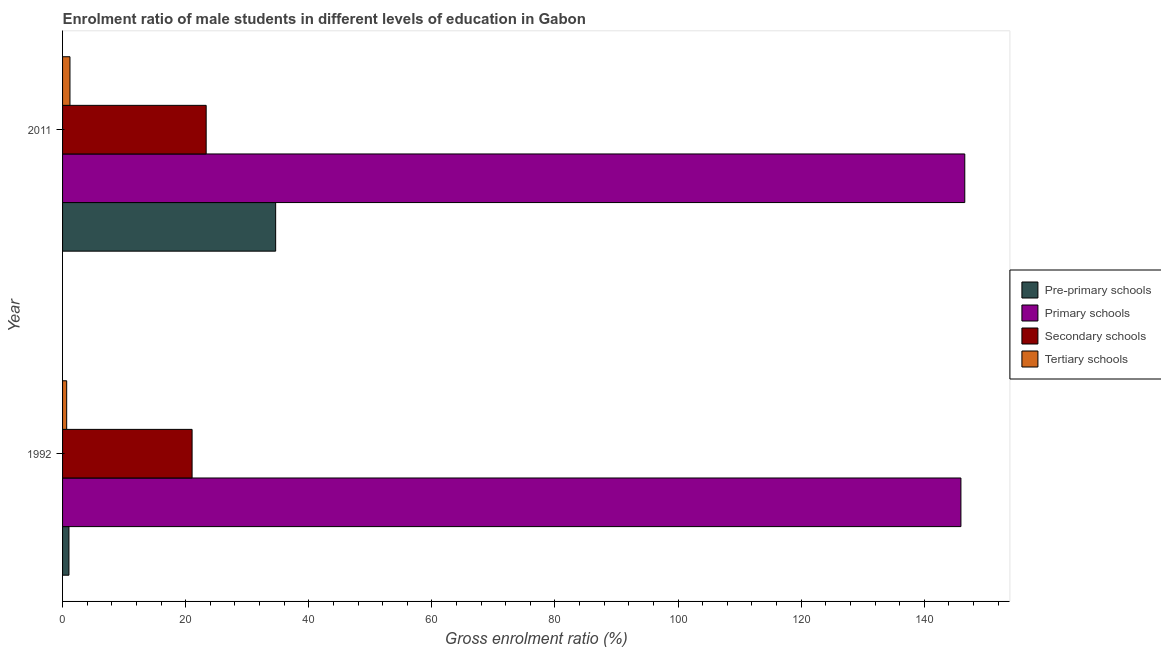How many different coloured bars are there?
Your response must be concise. 4. Are the number of bars per tick equal to the number of legend labels?
Give a very brief answer. Yes. How many bars are there on the 2nd tick from the top?
Ensure brevity in your answer.  4. How many bars are there on the 2nd tick from the bottom?
Provide a succinct answer. 4. What is the gross enrolment ratio(female) in pre-primary schools in 1992?
Your answer should be compact. 1.04. Across all years, what is the maximum gross enrolment ratio(female) in tertiary schools?
Provide a succinct answer. 1.2. Across all years, what is the minimum gross enrolment ratio(female) in primary schools?
Your answer should be very brief. 145.96. What is the total gross enrolment ratio(female) in secondary schools in the graph?
Offer a very short reply. 44.38. What is the difference between the gross enrolment ratio(female) in pre-primary schools in 1992 and that in 2011?
Your answer should be compact. -33.59. What is the difference between the gross enrolment ratio(female) in secondary schools in 1992 and the gross enrolment ratio(female) in tertiary schools in 2011?
Your answer should be very brief. 19.84. What is the average gross enrolment ratio(female) in tertiary schools per year?
Provide a succinct answer. 0.94. In the year 2011, what is the difference between the gross enrolment ratio(female) in primary schools and gross enrolment ratio(female) in tertiary schools?
Offer a very short reply. 145.39. In how many years, is the gross enrolment ratio(female) in tertiary schools greater than 36 %?
Keep it short and to the point. 0. What is the ratio of the gross enrolment ratio(female) in secondary schools in 1992 to that in 2011?
Keep it short and to the point. 0.9. Is the gross enrolment ratio(female) in tertiary schools in 1992 less than that in 2011?
Ensure brevity in your answer.  Yes. Is the difference between the gross enrolment ratio(female) in pre-primary schools in 1992 and 2011 greater than the difference between the gross enrolment ratio(female) in tertiary schools in 1992 and 2011?
Offer a very short reply. No. Is it the case that in every year, the sum of the gross enrolment ratio(female) in pre-primary schools and gross enrolment ratio(female) in tertiary schools is greater than the sum of gross enrolment ratio(female) in primary schools and gross enrolment ratio(female) in secondary schools?
Provide a succinct answer. No. What does the 1st bar from the top in 2011 represents?
Make the answer very short. Tertiary schools. What does the 1st bar from the bottom in 1992 represents?
Provide a succinct answer. Pre-primary schools. Is it the case that in every year, the sum of the gross enrolment ratio(female) in pre-primary schools and gross enrolment ratio(female) in primary schools is greater than the gross enrolment ratio(female) in secondary schools?
Your answer should be compact. Yes. Are the values on the major ticks of X-axis written in scientific E-notation?
Give a very brief answer. No. Does the graph contain grids?
Give a very brief answer. No. How many legend labels are there?
Make the answer very short. 4. How are the legend labels stacked?
Ensure brevity in your answer.  Vertical. What is the title of the graph?
Offer a terse response. Enrolment ratio of male students in different levels of education in Gabon. Does "WFP" appear as one of the legend labels in the graph?
Give a very brief answer. No. What is the label or title of the X-axis?
Keep it short and to the point. Gross enrolment ratio (%). What is the Gross enrolment ratio (%) in Pre-primary schools in 1992?
Offer a terse response. 1.04. What is the Gross enrolment ratio (%) in Primary schools in 1992?
Offer a very short reply. 145.96. What is the Gross enrolment ratio (%) of Secondary schools in 1992?
Give a very brief answer. 21.04. What is the Gross enrolment ratio (%) in Tertiary schools in 1992?
Your response must be concise. 0.67. What is the Gross enrolment ratio (%) in Pre-primary schools in 2011?
Give a very brief answer. 34.62. What is the Gross enrolment ratio (%) in Primary schools in 2011?
Provide a short and direct response. 146.59. What is the Gross enrolment ratio (%) in Secondary schools in 2011?
Provide a succinct answer. 23.33. What is the Gross enrolment ratio (%) of Tertiary schools in 2011?
Provide a succinct answer. 1.2. Across all years, what is the maximum Gross enrolment ratio (%) in Pre-primary schools?
Provide a short and direct response. 34.62. Across all years, what is the maximum Gross enrolment ratio (%) in Primary schools?
Your answer should be very brief. 146.59. Across all years, what is the maximum Gross enrolment ratio (%) of Secondary schools?
Make the answer very short. 23.33. Across all years, what is the maximum Gross enrolment ratio (%) of Tertiary schools?
Keep it short and to the point. 1.2. Across all years, what is the minimum Gross enrolment ratio (%) in Pre-primary schools?
Keep it short and to the point. 1.04. Across all years, what is the minimum Gross enrolment ratio (%) in Primary schools?
Your response must be concise. 145.96. Across all years, what is the minimum Gross enrolment ratio (%) in Secondary schools?
Ensure brevity in your answer.  21.04. Across all years, what is the minimum Gross enrolment ratio (%) in Tertiary schools?
Offer a terse response. 0.67. What is the total Gross enrolment ratio (%) in Pre-primary schools in the graph?
Ensure brevity in your answer.  35.66. What is the total Gross enrolment ratio (%) of Primary schools in the graph?
Offer a terse response. 292.55. What is the total Gross enrolment ratio (%) of Secondary schools in the graph?
Your answer should be very brief. 44.38. What is the total Gross enrolment ratio (%) of Tertiary schools in the graph?
Give a very brief answer. 1.87. What is the difference between the Gross enrolment ratio (%) of Pre-primary schools in 1992 and that in 2011?
Your answer should be compact. -33.59. What is the difference between the Gross enrolment ratio (%) in Primary schools in 1992 and that in 2011?
Make the answer very short. -0.63. What is the difference between the Gross enrolment ratio (%) of Secondary schools in 1992 and that in 2011?
Offer a very short reply. -2.29. What is the difference between the Gross enrolment ratio (%) of Tertiary schools in 1992 and that in 2011?
Your response must be concise. -0.53. What is the difference between the Gross enrolment ratio (%) in Pre-primary schools in 1992 and the Gross enrolment ratio (%) in Primary schools in 2011?
Provide a short and direct response. -145.55. What is the difference between the Gross enrolment ratio (%) of Pre-primary schools in 1992 and the Gross enrolment ratio (%) of Secondary schools in 2011?
Provide a short and direct response. -22.3. What is the difference between the Gross enrolment ratio (%) in Pre-primary schools in 1992 and the Gross enrolment ratio (%) in Tertiary schools in 2011?
Give a very brief answer. -0.17. What is the difference between the Gross enrolment ratio (%) in Primary schools in 1992 and the Gross enrolment ratio (%) in Secondary schools in 2011?
Offer a very short reply. 122.63. What is the difference between the Gross enrolment ratio (%) in Primary schools in 1992 and the Gross enrolment ratio (%) in Tertiary schools in 2011?
Your answer should be very brief. 144.76. What is the difference between the Gross enrolment ratio (%) of Secondary schools in 1992 and the Gross enrolment ratio (%) of Tertiary schools in 2011?
Provide a short and direct response. 19.84. What is the average Gross enrolment ratio (%) in Pre-primary schools per year?
Keep it short and to the point. 17.83. What is the average Gross enrolment ratio (%) in Primary schools per year?
Your answer should be very brief. 146.27. What is the average Gross enrolment ratio (%) of Secondary schools per year?
Make the answer very short. 22.19. What is the average Gross enrolment ratio (%) of Tertiary schools per year?
Ensure brevity in your answer.  0.94. In the year 1992, what is the difference between the Gross enrolment ratio (%) in Pre-primary schools and Gross enrolment ratio (%) in Primary schools?
Offer a very short reply. -144.92. In the year 1992, what is the difference between the Gross enrolment ratio (%) in Pre-primary schools and Gross enrolment ratio (%) in Secondary schools?
Offer a terse response. -20.01. In the year 1992, what is the difference between the Gross enrolment ratio (%) in Pre-primary schools and Gross enrolment ratio (%) in Tertiary schools?
Offer a very short reply. 0.37. In the year 1992, what is the difference between the Gross enrolment ratio (%) of Primary schools and Gross enrolment ratio (%) of Secondary schools?
Offer a terse response. 124.92. In the year 1992, what is the difference between the Gross enrolment ratio (%) of Primary schools and Gross enrolment ratio (%) of Tertiary schools?
Your answer should be compact. 145.29. In the year 1992, what is the difference between the Gross enrolment ratio (%) in Secondary schools and Gross enrolment ratio (%) in Tertiary schools?
Provide a short and direct response. 20.37. In the year 2011, what is the difference between the Gross enrolment ratio (%) of Pre-primary schools and Gross enrolment ratio (%) of Primary schools?
Provide a succinct answer. -111.97. In the year 2011, what is the difference between the Gross enrolment ratio (%) of Pre-primary schools and Gross enrolment ratio (%) of Secondary schools?
Ensure brevity in your answer.  11.29. In the year 2011, what is the difference between the Gross enrolment ratio (%) in Pre-primary schools and Gross enrolment ratio (%) in Tertiary schools?
Make the answer very short. 33.42. In the year 2011, what is the difference between the Gross enrolment ratio (%) of Primary schools and Gross enrolment ratio (%) of Secondary schools?
Keep it short and to the point. 123.25. In the year 2011, what is the difference between the Gross enrolment ratio (%) of Primary schools and Gross enrolment ratio (%) of Tertiary schools?
Offer a very short reply. 145.39. In the year 2011, what is the difference between the Gross enrolment ratio (%) of Secondary schools and Gross enrolment ratio (%) of Tertiary schools?
Keep it short and to the point. 22.13. What is the ratio of the Gross enrolment ratio (%) in Pre-primary schools in 1992 to that in 2011?
Give a very brief answer. 0.03. What is the ratio of the Gross enrolment ratio (%) in Secondary schools in 1992 to that in 2011?
Your response must be concise. 0.9. What is the ratio of the Gross enrolment ratio (%) in Tertiary schools in 1992 to that in 2011?
Ensure brevity in your answer.  0.56. What is the difference between the highest and the second highest Gross enrolment ratio (%) of Pre-primary schools?
Keep it short and to the point. 33.59. What is the difference between the highest and the second highest Gross enrolment ratio (%) of Primary schools?
Ensure brevity in your answer.  0.63. What is the difference between the highest and the second highest Gross enrolment ratio (%) in Secondary schools?
Keep it short and to the point. 2.29. What is the difference between the highest and the second highest Gross enrolment ratio (%) in Tertiary schools?
Provide a short and direct response. 0.53. What is the difference between the highest and the lowest Gross enrolment ratio (%) of Pre-primary schools?
Your answer should be very brief. 33.59. What is the difference between the highest and the lowest Gross enrolment ratio (%) of Primary schools?
Ensure brevity in your answer.  0.63. What is the difference between the highest and the lowest Gross enrolment ratio (%) in Secondary schools?
Give a very brief answer. 2.29. What is the difference between the highest and the lowest Gross enrolment ratio (%) in Tertiary schools?
Make the answer very short. 0.53. 